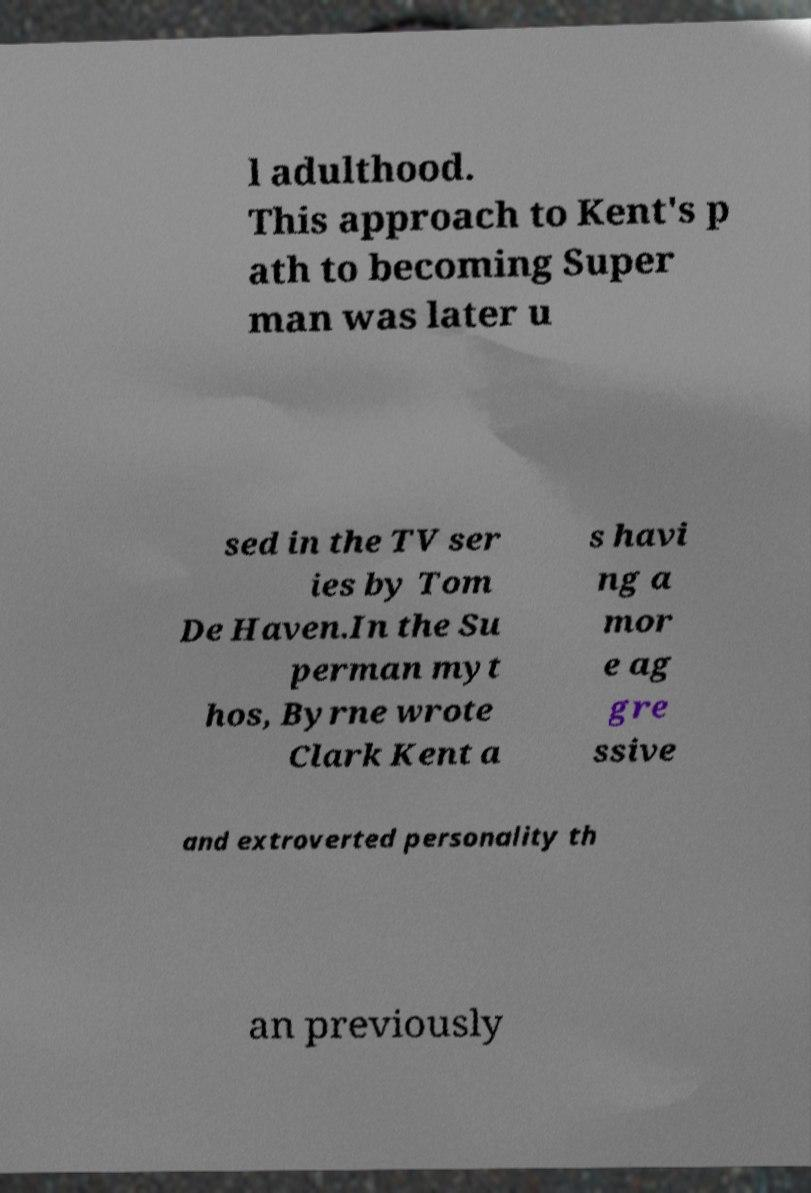What messages or text are displayed in this image? I need them in a readable, typed format. l adulthood. This approach to Kent's p ath to becoming Super man was later u sed in the TV ser ies by Tom De Haven.In the Su perman myt hos, Byrne wrote Clark Kent a s havi ng a mor e ag gre ssive and extroverted personality th an previously 